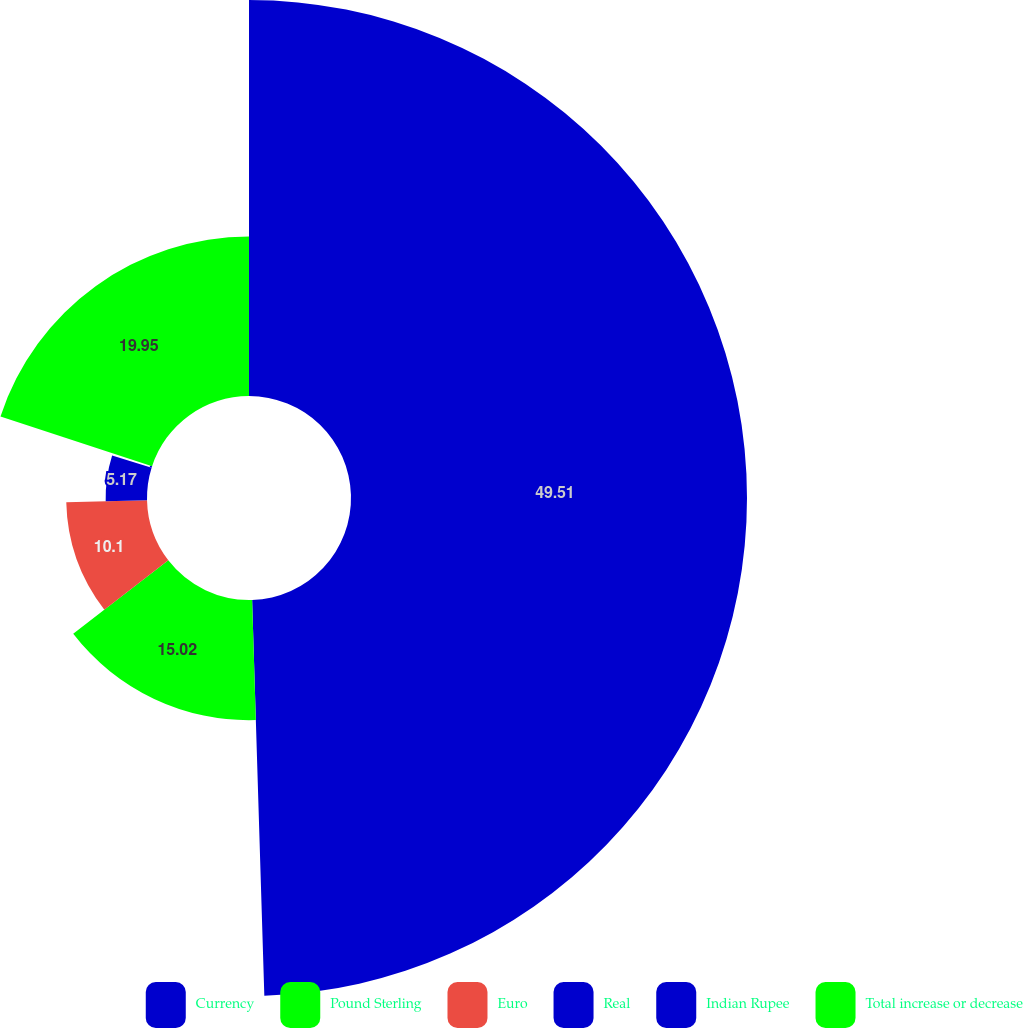Convert chart. <chart><loc_0><loc_0><loc_500><loc_500><pie_chart><fcel>Currency<fcel>Pound Sterling<fcel>Euro<fcel>Real<fcel>Indian Rupee<fcel>Total increase or decrease<nl><fcel>49.51%<fcel>15.02%<fcel>10.1%<fcel>5.17%<fcel>0.25%<fcel>19.95%<nl></chart> 